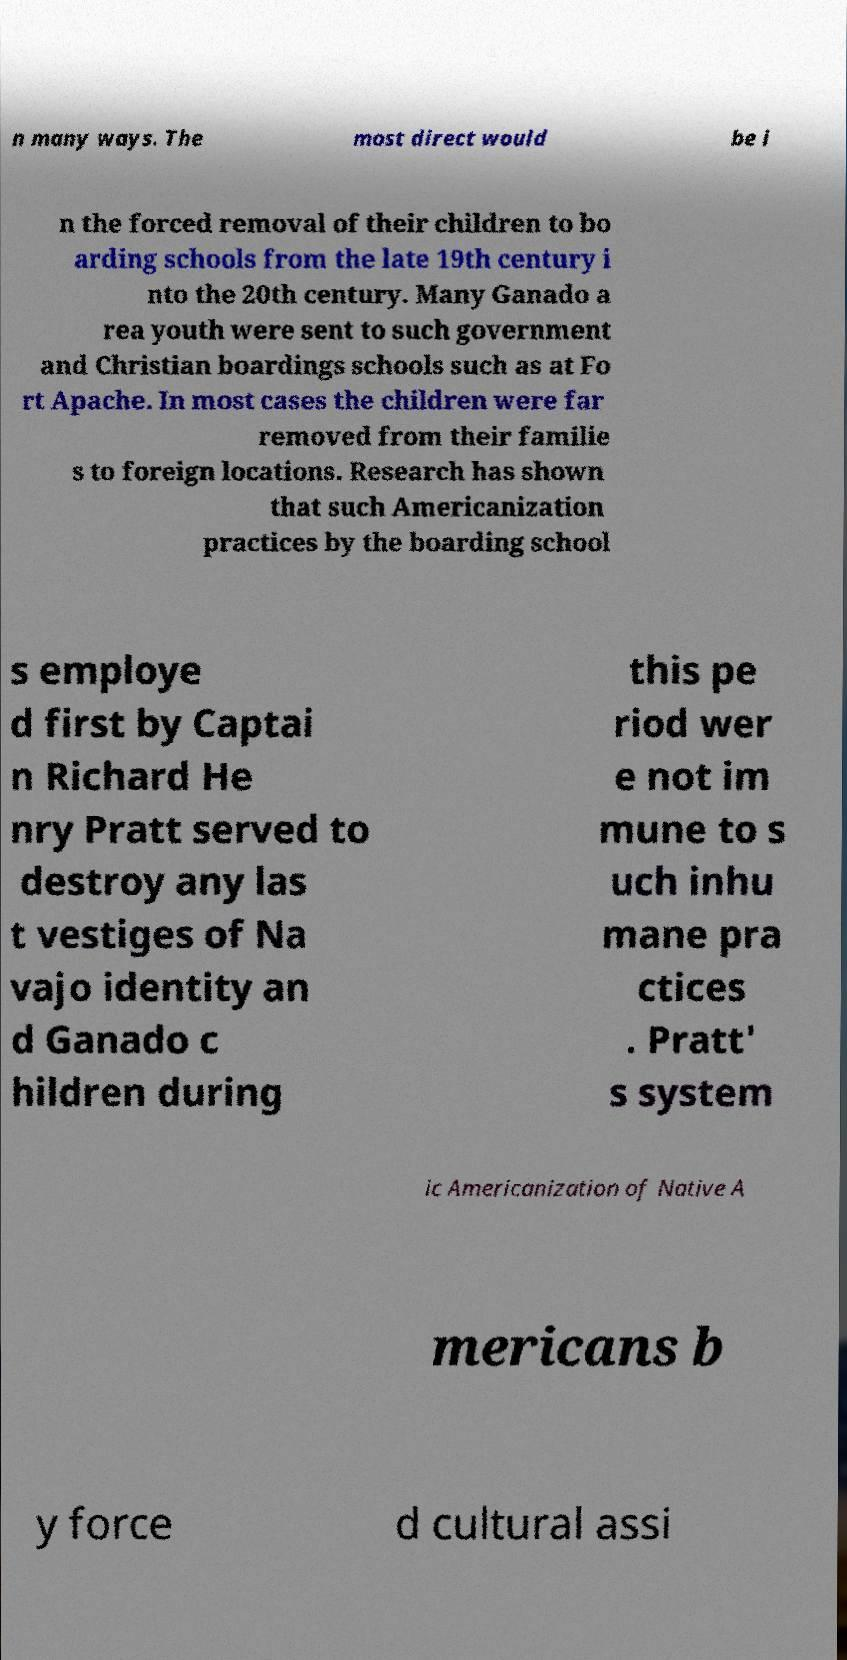Can you accurately transcribe the text from the provided image for me? n many ways. The most direct would be i n the forced removal of their children to bo arding schools from the late 19th century i nto the 20th century. Many Ganado a rea youth were sent to such government and Christian boardings schools such as at Fo rt Apache. In most cases the children were far removed from their familie s to foreign locations. Research has shown that such Americanization practices by the boarding school s employe d first by Captai n Richard He nry Pratt served to destroy any las t vestiges of Na vajo identity an d Ganado c hildren during this pe riod wer e not im mune to s uch inhu mane pra ctices . Pratt' s system ic Americanization of Native A mericans b y force d cultural assi 